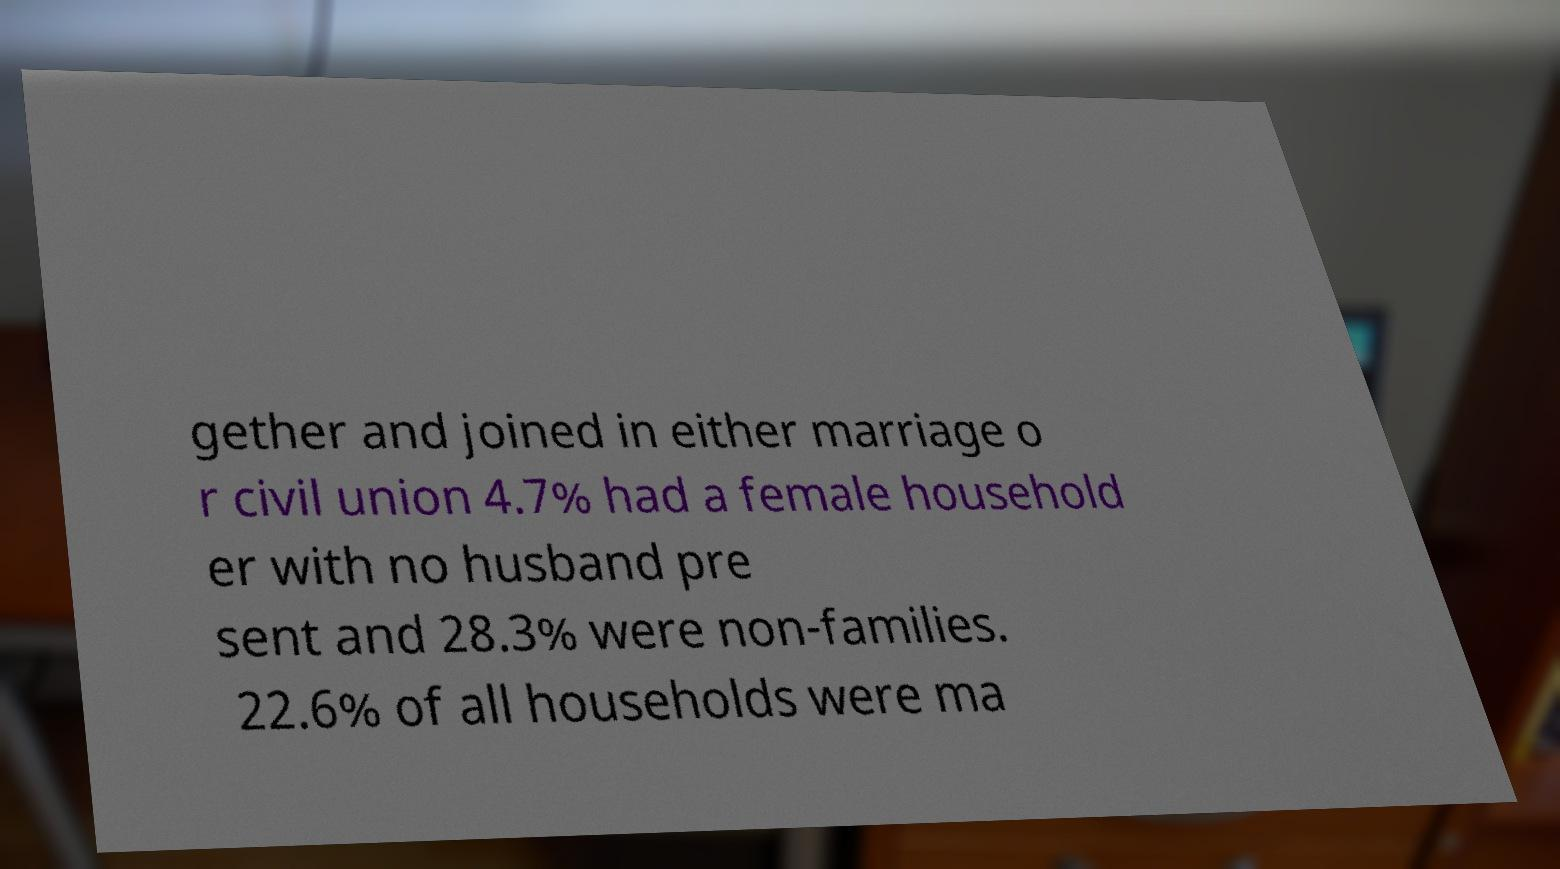For documentation purposes, I need the text within this image transcribed. Could you provide that? gether and joined in either marriage o r civil union 4.7% had a female household er with no husband pre sent and 28.3% were non-families. 22.6% of all households were ma 